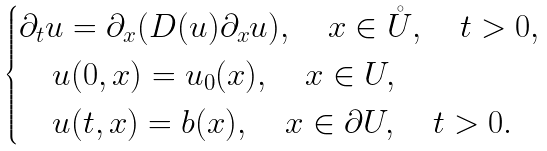<formula> <loc_0><loc_0><loc_500><loc_500>\begin{cases} \partial _ { t } u = \partial _ { x } ( D ( u ) \partial _ { x } u ) , \quad x \in { \mathring { U } } , \quad t > 0 , \\ \quad u ( 0 , x ) = u _ { 0 } ( x ) , \quad x \in U , \\ \quad u ( t , x ) = b ( x ) , \quad x \in \partial U , \quad t > 0 . \end{cases}</formula> 